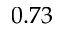<formula> <loc_0><loc_0><loc_500><loc_500>0 . 7 3</formula> 